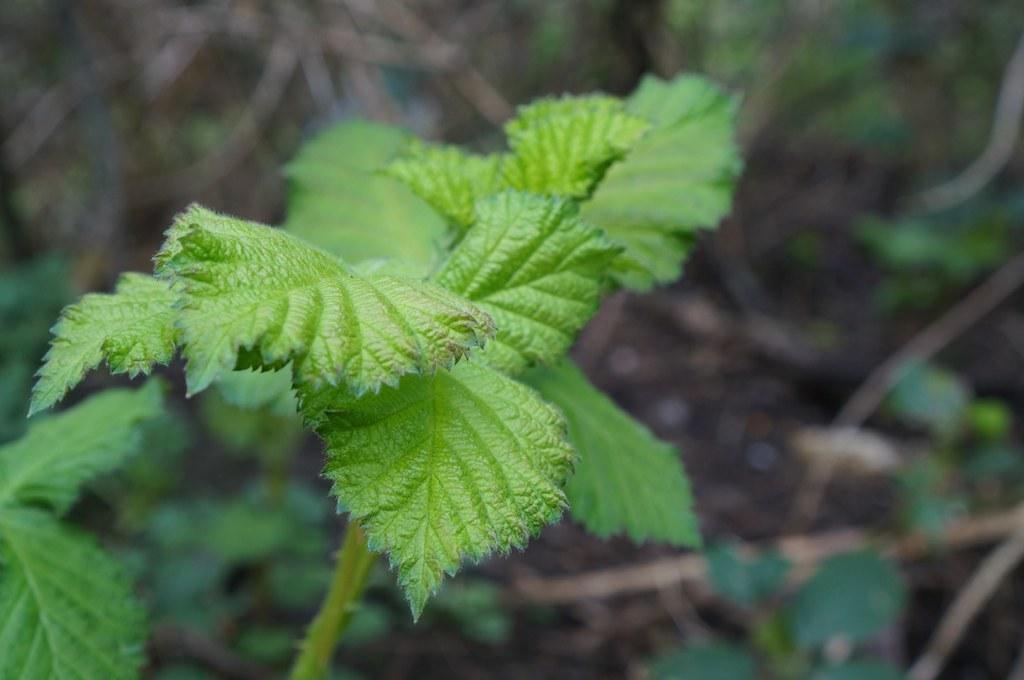How would you summarize this image in a sentence or two? In this picture, we see the plants. At the bottom, we see the soil, herbs and the twigs. In the background, it is in brown and green color. This picture is blurred in the background. 